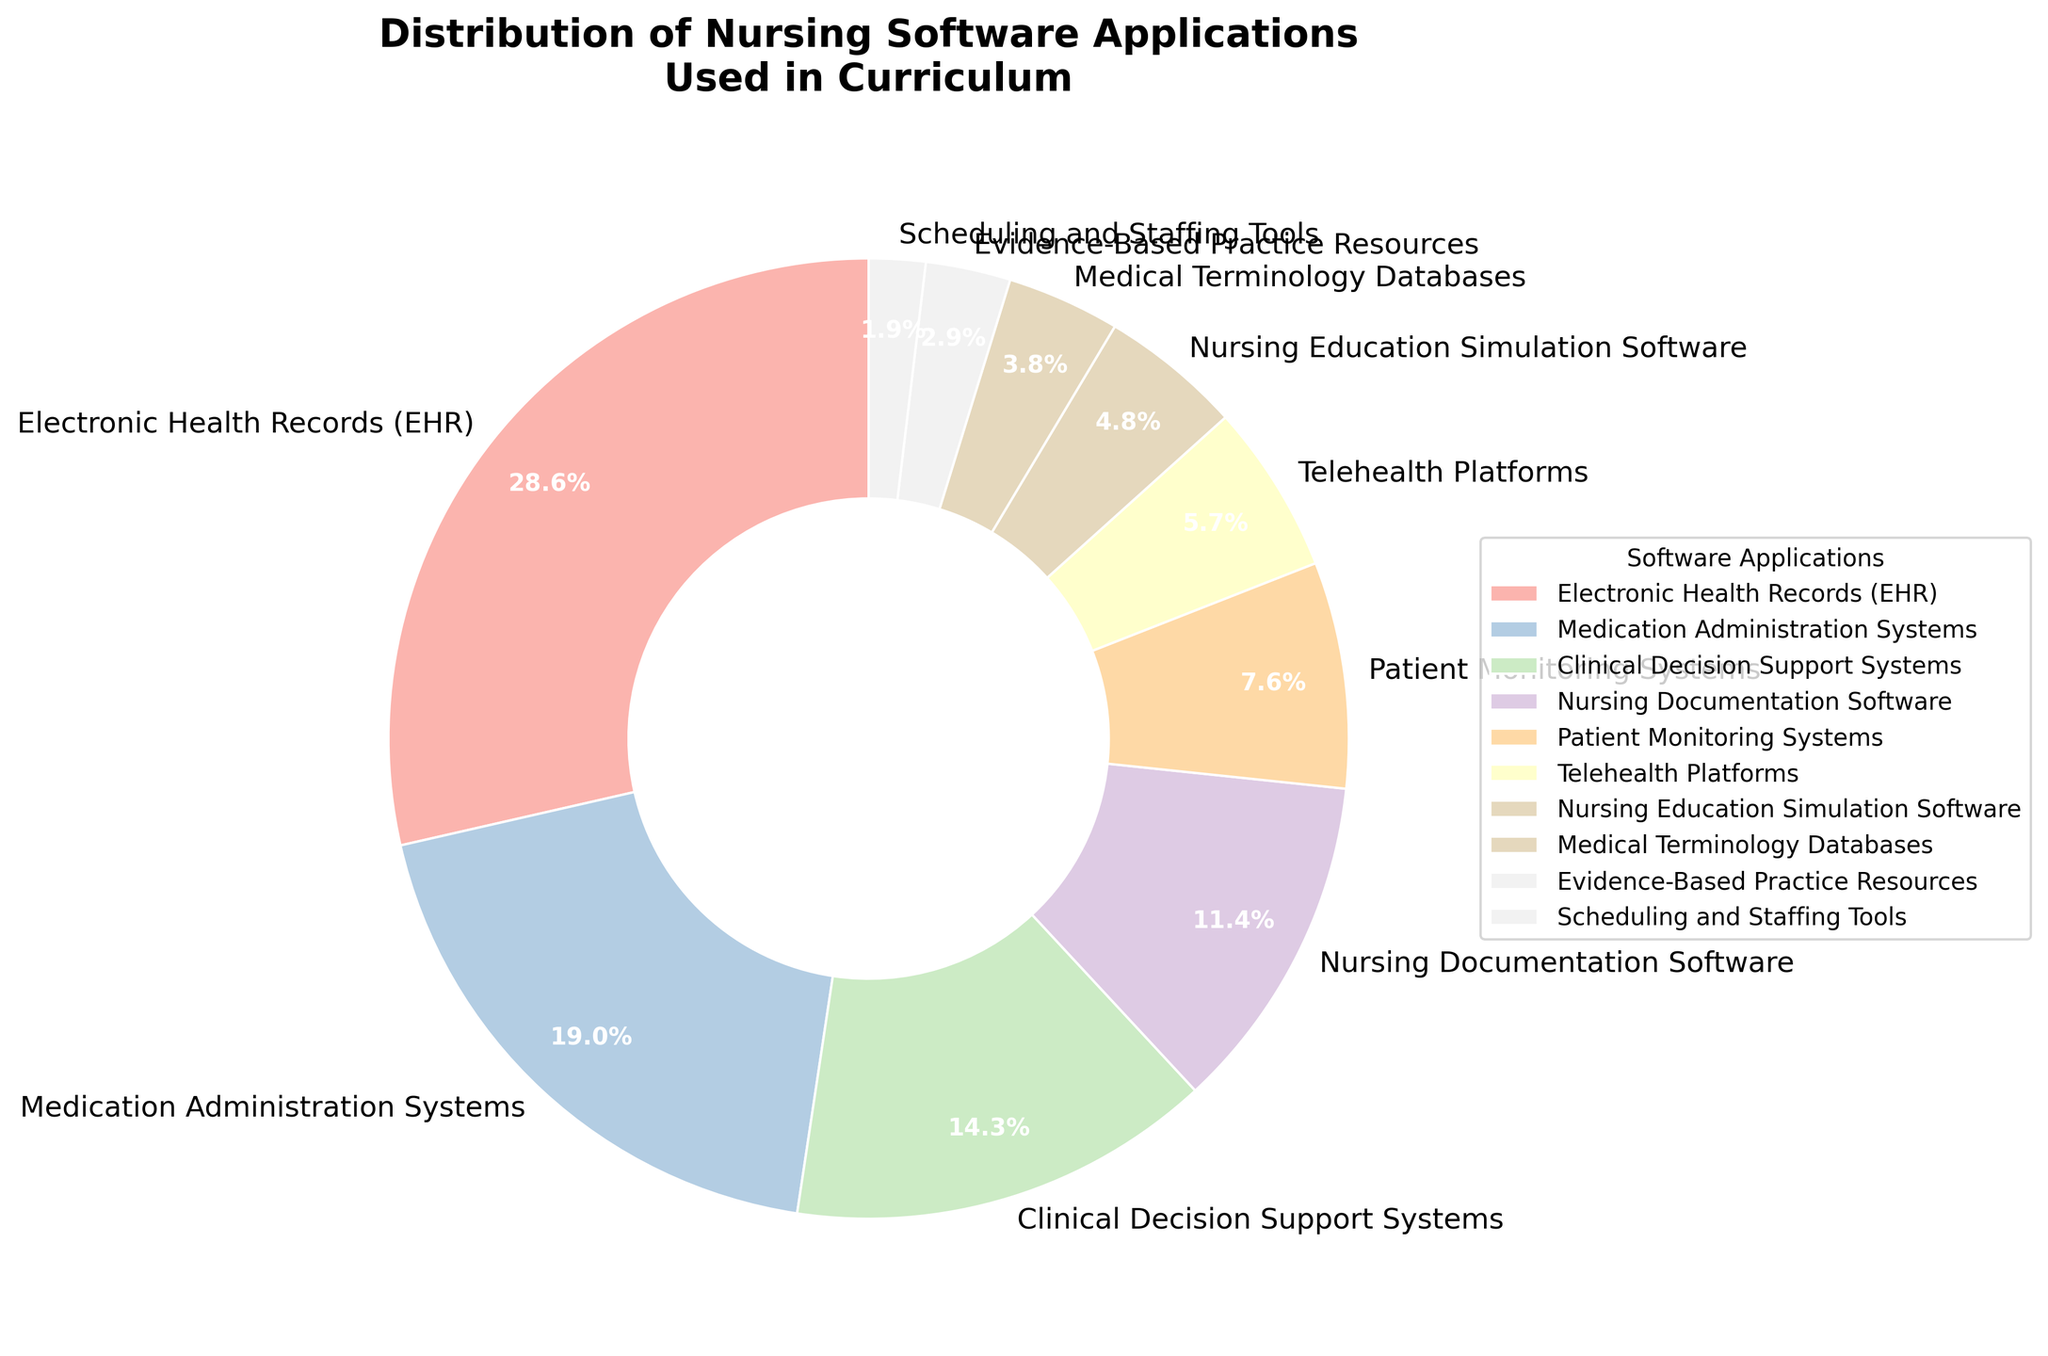Which software application has the highest usage percentage? The pie chart clearly shows that Electronic Health Records (EHR) has the largest section, corresponding to 30%.
Answer: Electronic Health Records (EHR) What is the combined percentage of Clinical Decision Support Systems, Nursing Documentation Software, and Patient Monitoring Systems? Add the percentages: Clinical Decision Support Systems (15%) + Nursing Documentation Software (12%) + Patient Monitoring Systems (8%) = 35%.
Answer: 35% Is the usage percentage of Medication Administration Systems greater than the usage percentage of Telehealth Platforms? Compare the sections of Medication Administration Systems (20%) and Telehealth Platforms (6%) in the pie chart. 20% is greater than 6%.
Answer: Yes Which software applications together make up less than 10% of the usage in the curriculum? Looking at the chart, the applications with percentages less than 10% are: Telehealth Platforms (6%), Nursing Education Simulation Software (5%), Medical Terminology Databases (4%), Evidence-Based Practice Resources (3%), and Scheduling and Staffing Tools (2%).
Answer: Telehealth Platforms, Nursing Education Simulation Software, Medical Terminology Databases, Evidence-Based Practice Resources, Scheduling and Staffing Tools How much larger is the usage percentage of Electronic Health Records compared to Nursing Documentation Software? Subtract the percentage of Nursing Documentation Software (12%) from Electronic Health Records (30%): 30% - 12% = 18%.
Answer: 18% Which software application has a percentage closest to 10%? Nursing Documentation Software has a usage percentage of 12%, which is closest to 10%.
Answer: Nursing Documentation Software What percentage of the curriculum is occupied by the smallest section? The smallest section of the pie chart is Scheduling and Staffing Tools, which has a usage percentage of 2%.
Answer: 2% Are the combined percentages of Patient Monitoring Systems and Nursing Documentation Software greater than the percentage of Medication Administration Systems? Add the percentages: Patient Monitoring Systems (8%) + Nursing Documentation Software (12%) = 20%. Compare it to Medication Administration Systems (20%). They are equal.
Answer: No Which software applications together constitute exactly half of the curriculum's usage percentage? Electronic Health Records (30%) + Medication Administration Systems (20%) = 50%.
Answer: Electronic Health Records, Medication Administration Systems How does the percentage for Clinical Decision Support Systems compare to that of Telehealth Platforms? Compare the sections: Clinical Decision Support Systems is 15% and Telehealth Platforms is 6%. 15% is more than 6%.
Answer: Clinical Decision Support Systems has a higher percentage than Telehealth Platforms 